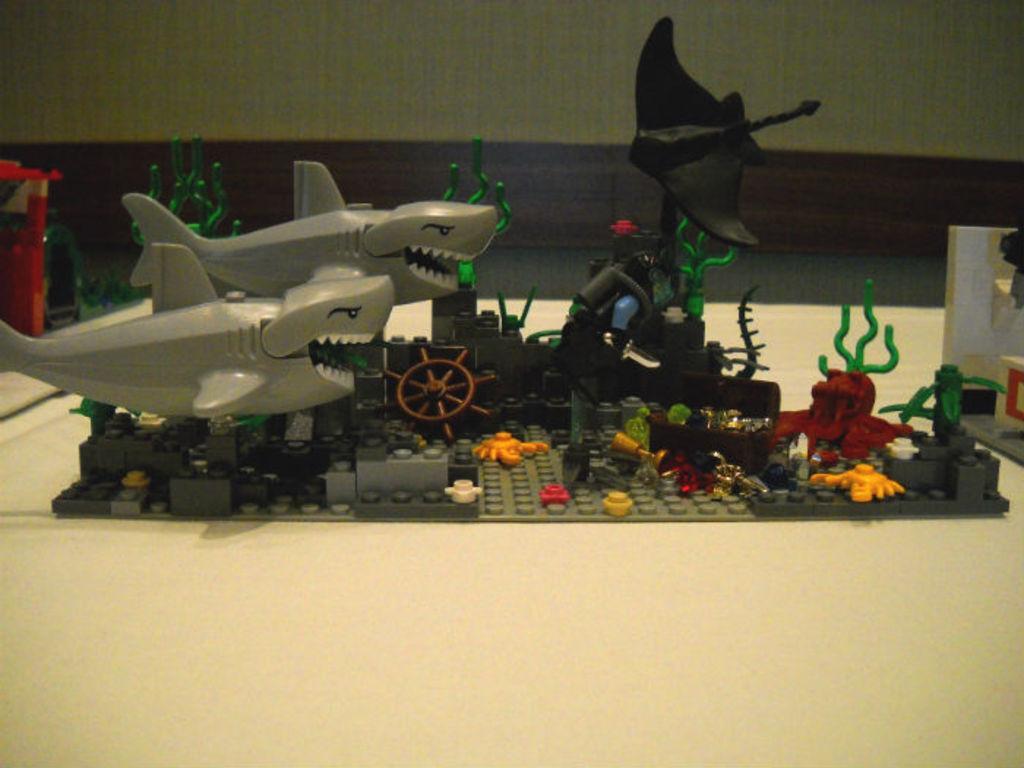Could you give a brief overview of what you see in this image? This image consists of a miniature and there are toys. These all are kept on the desk. In the background, we can see a wall. 